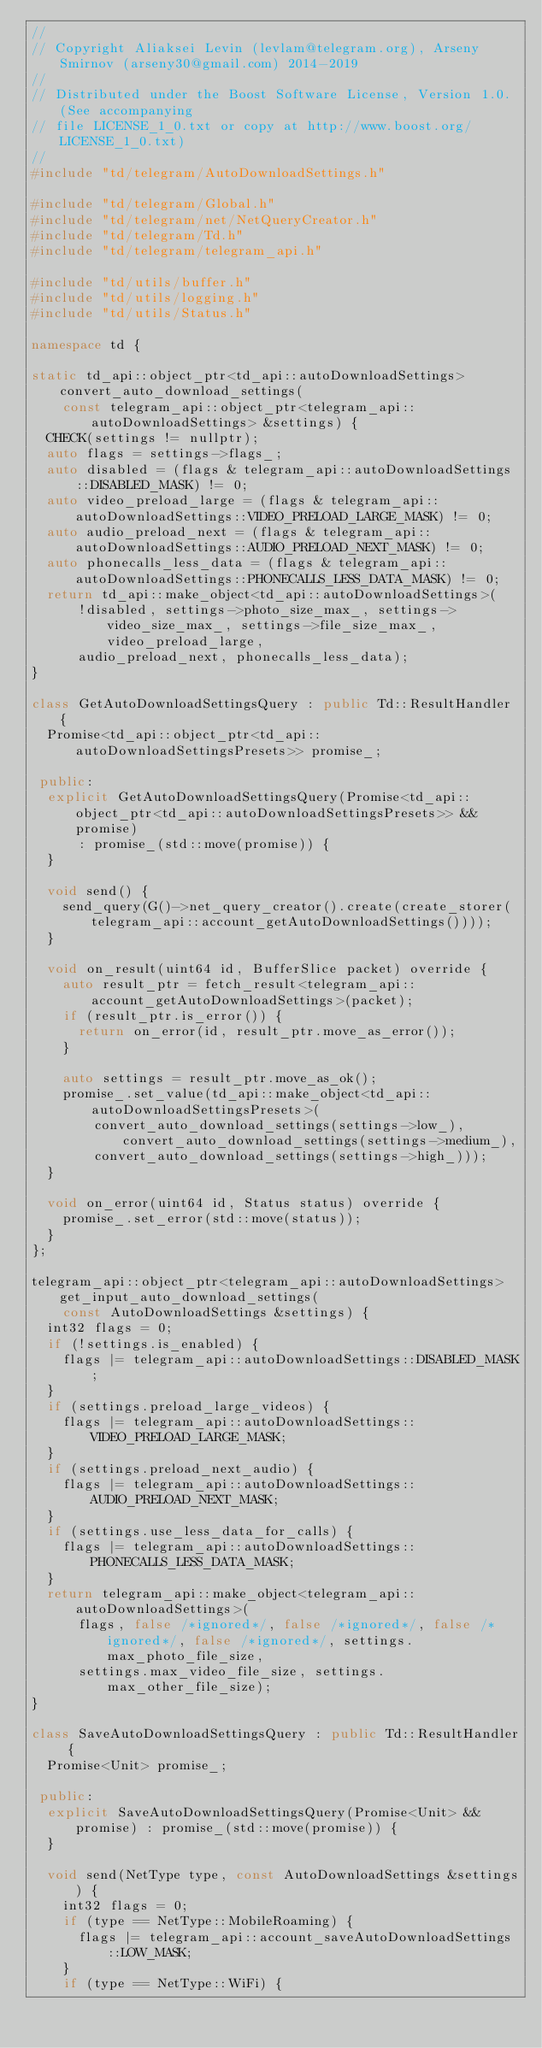Convert code to text. <code><loc_0><loc_0><loc_500><loc_500><_C++_>//
// Copyright Aliaksei Levin (levlam@telegram.org), Arseny Smirnov (arseny30@gmail.com) 2014-2019
//
// Distributed under the Boost Software License, Version 1.0. (See accompanying
// file LICENSE_1_0.txt or copy at http://www.boost.org/LICENSE_1_0.txt)
//
#include "td/telegram/AutoDownloadSettings.h"

#include "td/telegram/Global.h"
#include "td/telegram/net/NetQueryCreator.h"
#include "td/telegram/Td.h"
#include "td/telegram/telegram_api.h"

#include "td/utils/buffer.h"
#include "td/utils/logging.h"
#include "td/utils/Status.h"

namespace td {

static td_api::object_ptr<td_api::autoDownloadSettings> convert_auto_download_settings(
    const telegram_api::object_ptr<telegram_api::autoDownloadSettings> &settings) {
  CHECK(settings != nullptr);
  auto flags = settings->flags_;
  auto disabled = (flags & telegram_api::autoDownloadSettings::DISABLED_MASK) != 0;
  auto video_preload_large = (flags & telegram_api::autoDownloadSettings::VIDEO_PRELOAD_LARGE_MASK) != 0;
  auto audio_preload_next = (flags & telegram_api::autoDownloadSettings::AUDIO_PRELOAD_NEXT_MASK) != 0;
  auto phonecalls_less_data = (flags & telegram_api::autoDownloadSettings::PHONECALLS_LESS_DATA_MASK) != 0;
  return td_api::make_object<td_api::autoDownloadSettings>(
      !disabled, settings->photo_size_max_, settings->video_size_max_, settings->file_size_max_, video_preload_large,
      audio_preload_next, phonecalls_less_data);
}

class GetAutoDownloadSettingsQuery : public Td::ResultHandler {
  Promise<td_api::object_ptr<td_api::autoDownloadSettingsPresets>> promise_;

 public:
  explicit GetAutoDownloadSettingsQuery(Promise<td_api::object_ptr<td_api::autoDownloadSettingsPresets>> &&promise)
      : promise_(std::move(promise)) {
  }

  void send() {
    send_query(G()->net_query_creator().create(create_storer(telegram_api::account_getAutoDownloadSettings())));
  }

  void on_result(uint64 id, BufferSlice packet) override {
    auto result_ptr = fetch_result<telegram_api::account_getAutoDownloadSettings>(packet);
    if (result_ptr.is_error()) {
      return on_error(id, result_ptr.move_as_error());
    }

    auto settings = result_ptr.move_as_ok();
    promise_.set_value(td_api::make_object<td_api::autoDownloadSettingsPresets>(
        convert_auto_download_settings(settings->low_), convert_auto_download_settings(settings->medium_),
        convert_auto_download_settings(settings->high_)));
  }

  void on_error(uint64 id, Status status) override {
    promise_.set_error(std::move(status));
  }
};

telegram_api::object_ptr<telegram_api::autoDownloadSettings> get_input_auto_download_settings(
    const AutoDownloadSettings &settings) {
  int32 flags = 0;
  if (!settings.is_enabled) {
    flags |= telegram_api::autoDownloadSettings::DISABLED_MASK;
  }
  if (settings.preload_large_videos) {
    flags |= telegram_api::autoDownloadSettings::VIDEO_PRELOAD_LARGE_MASK;
  }
  if (settings.preload_next_audio) {
    flags |= telegram_api::autoDownloadSettings::AUDIO_PRELOAD_NEXT_MASK;
  }
  if (settings.use_less_data_for_calls) {
    flags |= telegram_api::autoDownloadSettings::PHONECALLS_LESS_DATA_MASK;
  }
  return telegram_api::make_object<telegram_api::autoDownloadSettings>(
      flags, false /*ignored*/, false /*ignored*/, false /*ignored*/, false /*ignored*/, settings.max_photo_file_size,
      settings.max_video_file_size, settings.max_other_file_size);
}

class SaveAutoDownloadSettingsQuery : public Td::ResultHandler {
  Promise<Unit> promise_;

 public:
  explicit SaveAutoDownloadSettingsQuery(Promise<Unit> &&promise) : promise_(std::move(promise)) {
  }

  void send(NetType type, const AutoDownloadSettings &settings) {
    int32 flags = 0;
    if (type == NetType::MobileRoaming) {
      flags |= telegram_api::account_saveAutoDownloadSettings::LOW_MASK;
    }
    if (type == NetType::WiFi) {</code> 